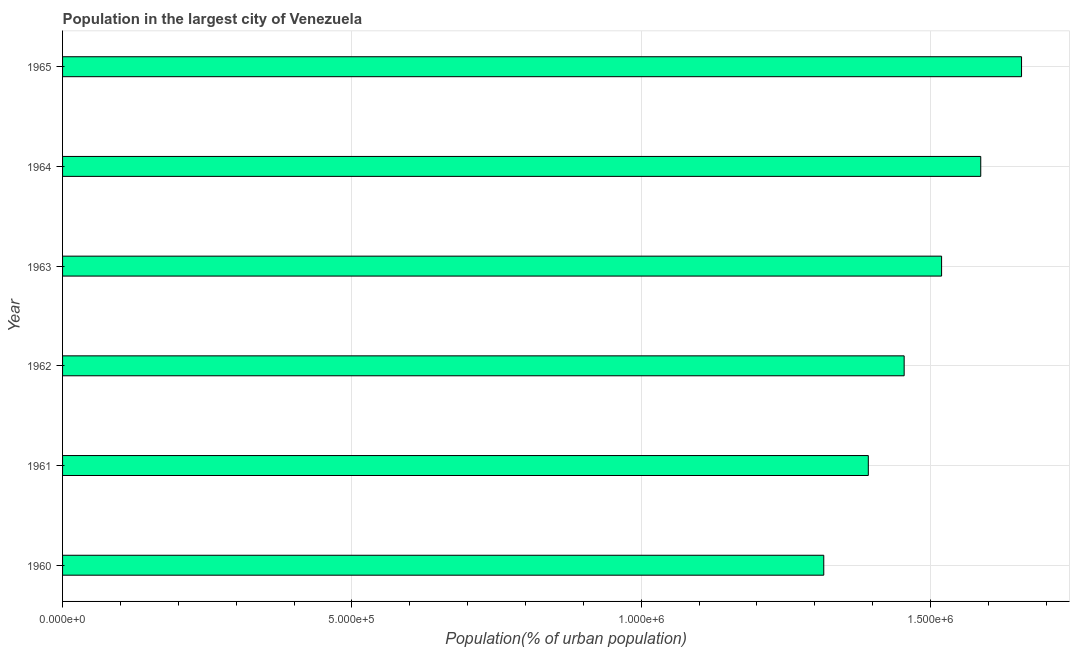Does the graph contain any zero values?
Offer a very short reply. No. Does the graph contain grids?
Offer a terse response. Yes. What is the title of the graph?
Your answer should be very brief. Population in the largest city of Venezuela. What is the label or title of the X-axis?
Your answer should be compact. Population(% of urban population). What is the population in largest city in 1964?
Offer a terse response. 1.59e+06. Across all years, what is the maximum population in largest city?
Offer a terse response. 1.66e+06. Across all years, what is the minimum population in largest city?
Your answer should be very brief. 1.32e+06. In which year was the population in largest city maximum?
Ensure brevity in your answer.  1965. In which year was the population in largest city minimum?
Provide a short and direct response. 1960. What is the sum of the population in largest city?
Offer a very short reply. 8.93e+06. What is the difference between the population in largest city in 1963 and 1964?
Your response must be concise. -6.77e+04. What is the average population in largest city per year?
Give a very brief answer. 1.49e+06. What is the median population in largest city?
Keep it short and to the point. 1.49e+06. In how many years, is the population in largest city greater than 1000000 %?
Keep it short and to the point. 6. Do a majority of the years between 1960 and 1963 (inclusive) have population in largest city greater than 1400000 %?
Make the answer very short. No. What is the ratio of the population in largest city in 1964 to that in 1965?
Your answer should be very brief. 0.96. Is the difference between the population in largest city in 1960 and 1964 greater than the difference between any two years?
Keep it short and to the point. No. What is the difference between the highest and the second highest population in largest city?
Provide a short and direct response. 7.05e+04. What is the difference between the highest and the lowest population in largest city?
Your answer should be compact. 3.42e+05. Are all the bars in the graph horizontal?
Your response must be concise. Yes. How many years are there in the graph?
Provide a short and direct response. 6. Are the values on the major ticks of X-axis written in scientific E-notation?
Ensure brevity in your answer.  Yes. What is the Population(% of urban population) of 1960?
Provide a short and direct response. 1.32e+06. What is the Population(% of urban population) of 1961?
Your answer should be very brief. 1.39e+06. What is the Population(% of urban population) in 1962?
Your answer should be very brief. 1.45e+06. What is the Population(% of urban population) of 1963?
Your response must be concise. 1.52e+06. What is the Population(% of urban population) of 1964?
Your response must be concise. 1.59e+06. What is the Population(% of urban population) of 1965?
Ensure brevity in your answer.  1.66e+06. What is the difference between the Population(% of urban population) in 1960 and 1961?
Make the answer very short. -7.70e+04. What is the difference between the Population(% of urban population) in 1960 and 1962?
Offer a terse response. -1.39e+05. What is the difference between the Population(% of urban population) in 1960 and 1963?
Your answer should be compact. -2.04e+05. What is the difference between the Population(% of urban population) in 1960 and 1964?
Offer a terse response. -2.71e+05. What is the difference between the Population(% of urban population) in 1960 and 1965?
Provide a short and direct response. -3.42e+05. What is the difference between the Population(% of urban population) in 1961 and 1962?
Your answer should be compact. -6.19e+04. What is the difference between the Population(% of urban population) in 1961 and 1963?
Offer a very short reply. -1.27e+05. What is the difference between the Population(% of urban population) in 1961 and 1964?
Provide a short and direct response. -1.94e+05. What is the difference between the Population(% of urban population) in 1961 and 1965?
Your answer should be compact. -2.65e+05. What is the difference between the Population(% of urban population) in 1962 and 1963?
Offer a very short reply. -6.47e+04. What is the difference between the Population(% of urban population) in 1962 and 1964?
Ensure brevity in your answer.  -1.32e+05. What is the difference between the Population(% of urban population) in 1962 and 1965?
Your response must be concise. -2.03e+05. What is the difference between the Population(% of urban population) in 1963 and 1964?
Make the answer very short. -6.77e+04. What is the difference between the Population(% of urban population) in 1963 and 1965?
Provide a succinct answer. -1.38e+05. What is the difference between the Population(% of urban population) in 1964 and 1965?
Your response must be concise. -7.05e+04. What is the ratio of the Population(% of urban population) in 1960 to that in 1961?
Give a very brief answer. 0.94. What is the ratio of the Population(% of urban population) in 1960 to that in 1962?
Ensure brevity in your answer.  0.9. What is the ratio of the Population(% of urban population) in 1960 to that in 1963?
Your answer should be compact. 0.87. What is the ratio of the Population(% of urban population) in 1960 to that in 1964?
Keep it short and to the point. 0.83. What is the ratio of the Population(% of urban population) in 1960 to that in 1965?
Your answer should be compact. 0.79. What is the ratio of the Population(% of urban population) in 1961 to that in 1962?
Keep it short and to the point. 0.96. What is the ratio of the Population(% of urban population) in 1961 to that in 1963?
Ensure brevity in your answer.  0.92. What is the ratio of the Population(% of urban population) in 1961 to that in 1964?
Give a very brief answer. 0.88. What is the ratio of the Population(% of urban population) in 1961 to that in 1965?
Keep it short and to the point. 0.84. What is the ratio of the Population(% of urban population) in 1962 to that in 1964?
Give a very brief answer. 0.92. What is the ratio of the Population(% of urban population) in 1962 to that in 1965?
Ensure brevity in your answer.  0.88. What is the ratio of the Population(% of urban population) in 1963 to that in 1965?
Offer a very short reply. 0.92. 